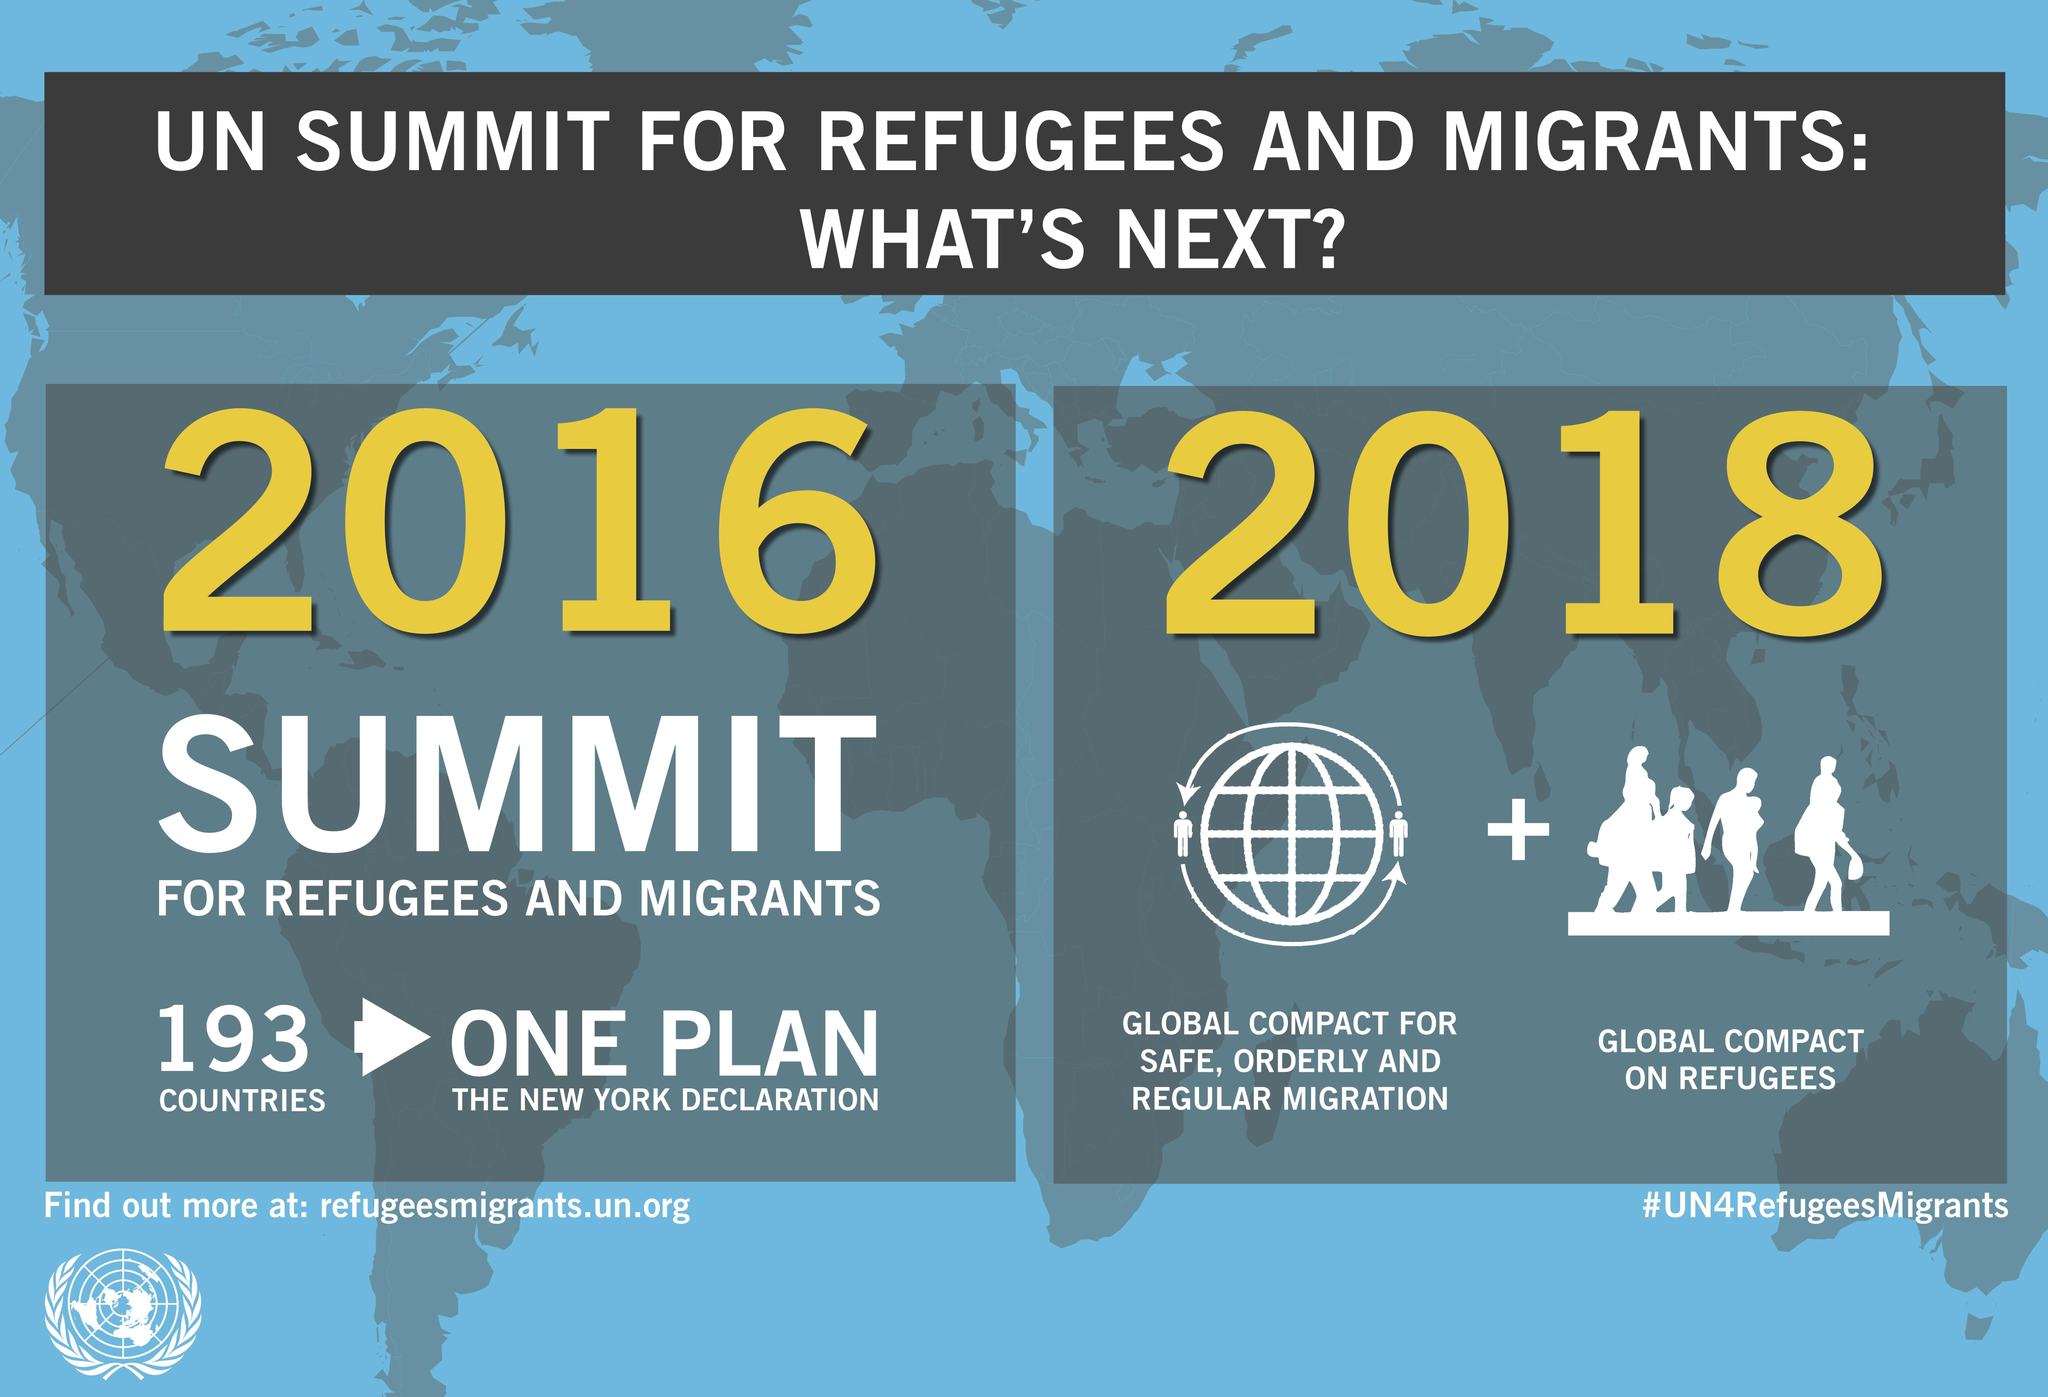Indicate a few pertinent items in this graphic. Nineteen-three countries participated in the summit. In addition to our commitment to the Global Compact on Refugees, we have also planned to participate in the Global Compact for Safe, Orderly and Regular Migration in 2018. The two years mentioned are 2016 and 2018. 